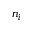Convert formula to latex. <formula><loc_0><loc_0><loc_500><loc_500>n _ { i }</formula> 